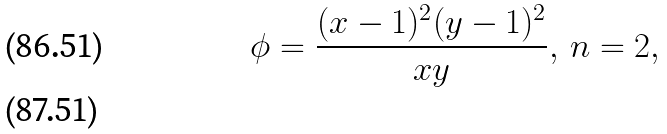Convert formula to latex. <formula><loc_0><loc_0><loc_500><loc_500>\phi = \frac { ( x - 1 ) ^ { 2 } ( y - 1 ) ^ { 2 } } { x y } , \, n = 2 , \\</formula> 